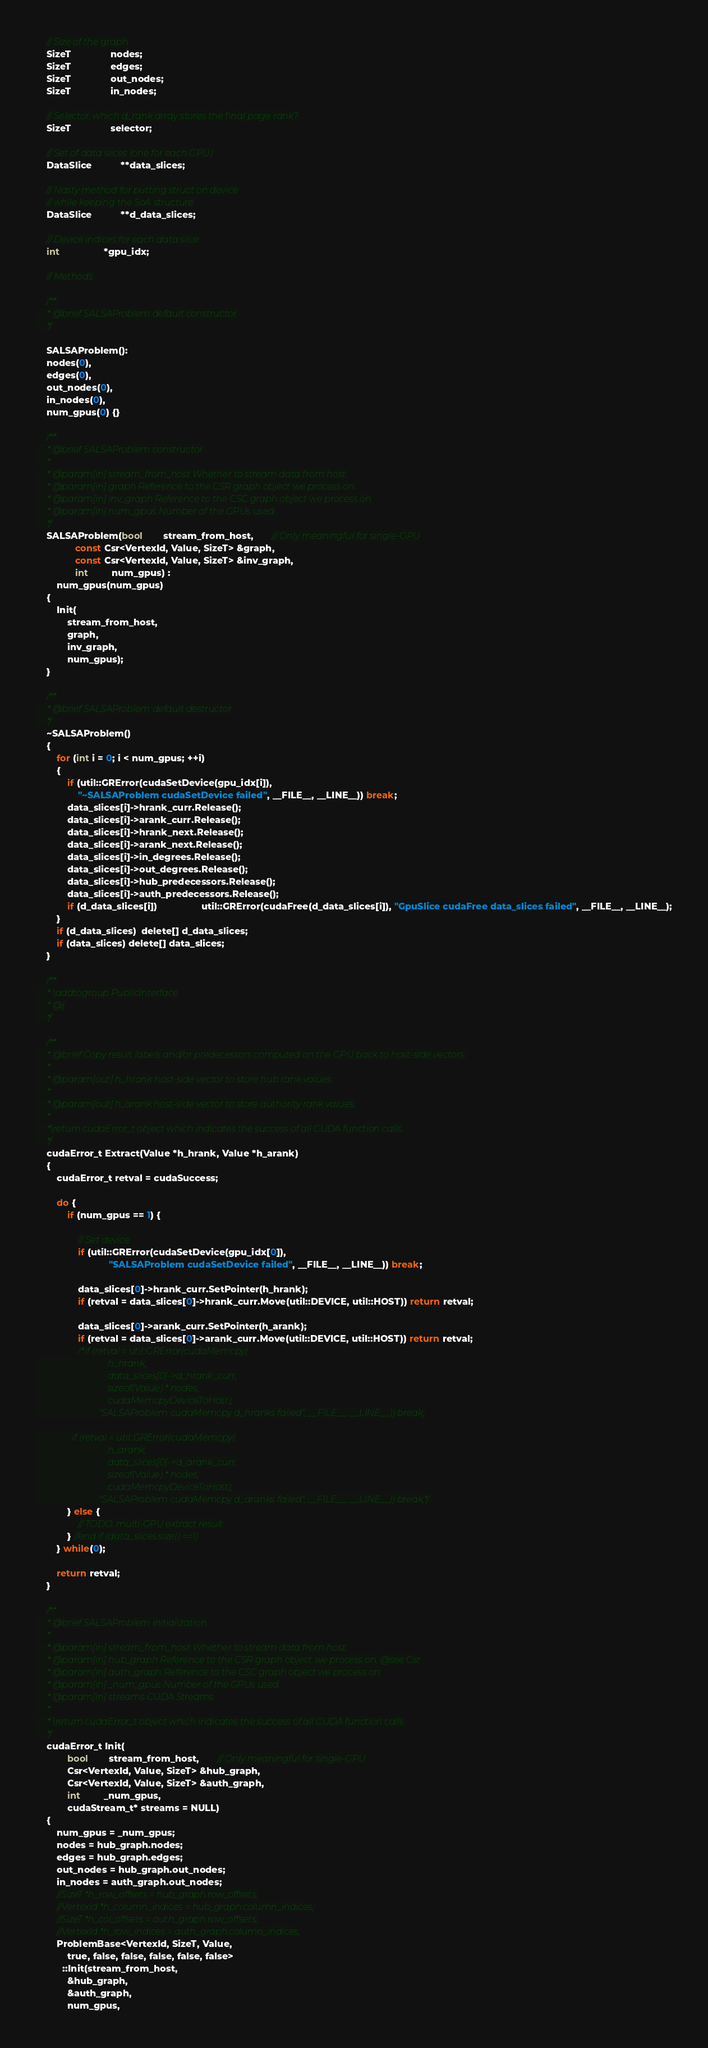<code> <loc_0><loc_0><loc_500><loc_500><_Cuda_>
    // Size of the graph
    SizeT               nodes;
    SizeT               edges;
    SizeT               out_nodes;
    SizeT               in_nodes;

    // Selector, which d_rank array stores the final page rank?
    SizeT               selector;

    // Set of data slices (one for each GPU)
    DataSlice           **data_slices;
   
    // Nasty method for putting struct on device
    // while keeping the SoA structure
    DataSlice           **d_data_slices;

    // Device indices for each data slice
    int                 *gpu_idx;

    // Methods

    /**
     * @brief SALSAProblem default constructor
     */

    SALSAProblem():
    nodes(0),
    edges(0),
    out_nodes(0),
    in_nodes(0),
    num_gpus(0) {}

    /**
     * @brief SALSAProblem constructor
     *
     * @param[in] stream_from_host Whether to stream data from host.
     * @param[in] graph Reference to the CSR graph object we process on.
     * @param[in] inv_graph Reference to the CSC graph object we process on.
     * @param[in] num_gpus Number of the GPUs used.
     */
    SALSAProblem(bool        stream_from_host,       // Only meaningful for single-GPU
               const Csr<VertexId, Value, SizeT> &graph,
               const Csr<VertexId, Value, SizeT> &inv_graph,
               int         num_gpus) :
        num_gpus(num_gpus)
    {
        Init(
            stream_from_host,
            graph,
            inv_graph,
            num_gpus);
    }

    /**
     * @brief SALSAProblem default destructor
     */
    ~SALSAProblem()
    {
        for (int i = 0; i < num_gpus; ++i)
        {
            if (util::GRError(cudaSetDevice(gpu_idx[i]),
                "~SALSAProblem cudaSetDevice failed", __FILE__, __LINE__)) break;
            data_slices[i]->hrank_curr.Release();
            data_slices[i]->arank_curr.Release();
            data_slices[i]->hrank_next.Release();
            data_slices[i]->arank_next.Release();
            data_slices[i]->in_degrees.Release();
            data_slices[i]->out_degrees.Release();
            data_slices[i]->hub_predecessors.Release();
            data_slices[i]->auth_predecessors.Release();
            if (d_data_slices[i])                 util::GRError(cudaFree(d_data_slices[i]), "GpuSlice cudaFree data_slices failed", __FILE__, __LINE__);
        }
        if (d_data_slices)  delete[] d_data_slices;
        if (data_slices) delete[] data_slices;
    }

    /**
     * \addtogroup PublicInterface
     * @{
     */

    /**
     * @brief Copy result labels and/or predecessors computed on the GPU back to host-side vectors.
     *
     * @param[out] h_hrank host-side vector to store hub rank values.
     *
     * @param[out] h_arank host-side vector to store authority rank values.
     *
     *\return cudaError_t object which indicates the success of all CUDA function calls.
     */
    cudaError_t Extract(Value *h_hrank, Value *h_arank)
    {
        cudaError_t retval = cudaSuccess;

        do {
            if (num_gpus == 1) {

                // Set device
                if (util::GRError(cudaSetDevice(gpu_idx[0]),
                            "SALSAProblem cudaSetDevice failed", __FILE__, __LINE__)) break;

                data_slices[0]->hrank_curr.SetPointer(h_hrank);
                if (retval = data_slices[0]->hrank_curr.Move(util::DEVICE, util::HOST)) return retval;

                data_slices[0]->arank_curr.SetPointer(h_arank);
                if (retval = data_slices[0]->arank_curr.Move(util::DEVICE, util::HOST)) return retval;
                /*if (retval = util::GRError(cudaMemcpy(
                                h_hrank,
                                data_slices[0]->d_hrank_curr,
                                sizeof(Value) * nodes,
                                cudaMemcpyDeviceToHost),
                            "SALSAProblem cudaMemcpy d_hranks failed", __FILE__, __LINE__)) break;

                if (retval = util::GRError(cudaMemcpy(
                                h_arank,
                                data_slices[0]->d_arank_curr,
                                sizeof(Value) * nodes,
                                cudaMemcpyDeviceToHost),
                            "SALSAProblem cudaMemcpy d_aranks failed", __FILE__, __LINE__)) break;*/
            } else {
                // TODO: multi-GPU extract result
            } //end if (data_slices.size() ==1)
        } while(0);

        return retval;
    }

    /**
     * @brief SALSAProblem initialization
     *
     * @param[in] stream_from_host Whether to stream data from host.
     * @param[in] hub_graph Reference to the CSR graph object we process on. @see Csr
     * @param[in] auth_graph Reference to the CSC graph object we process on.
     * @param[in] _num_gpus Number of the GPUs used.
     * @param[in] streams CUDA Streams
     *
     * \return cudaError_t object which indicates the success of all CUDA function calls.
     */
    cudaError_t Init(
            bool        stream_from_host,       // Only meaningful for single-GPU
            Csr<VertexId, Value, SizeT> &hub_graph,
            Csr<VertexId, Value, SizeT> &auth_graph,
            int         _num_gpus,
            cudaStream_t* streams = NULL)
    {
        num_gpus = _num_gpus;
        nodes = hub_graph.nodes;
        edges = hub_graph.edges;
        out_nodes = hub_graph.out_nodes;
        in_nodes = auth_graph.out_nodes;
        //SizeT *h_row_offsets = hub_graph.row_offsets;
        //VertexId *h_column_indices = hub_graph.column_indices;
        //SizeT *h_col_offsets = auth_graph.row_offsets;
        //VertexId *h_row_indices = auth_graph.column_indices;
        ProblemBase<VertexId, SizeT, Value, 
            true, false, false, false, false, false>
          ::Init(stream_from_host,
            &hub_graph,
            &auth_graph,
            num_gpus,</code> 